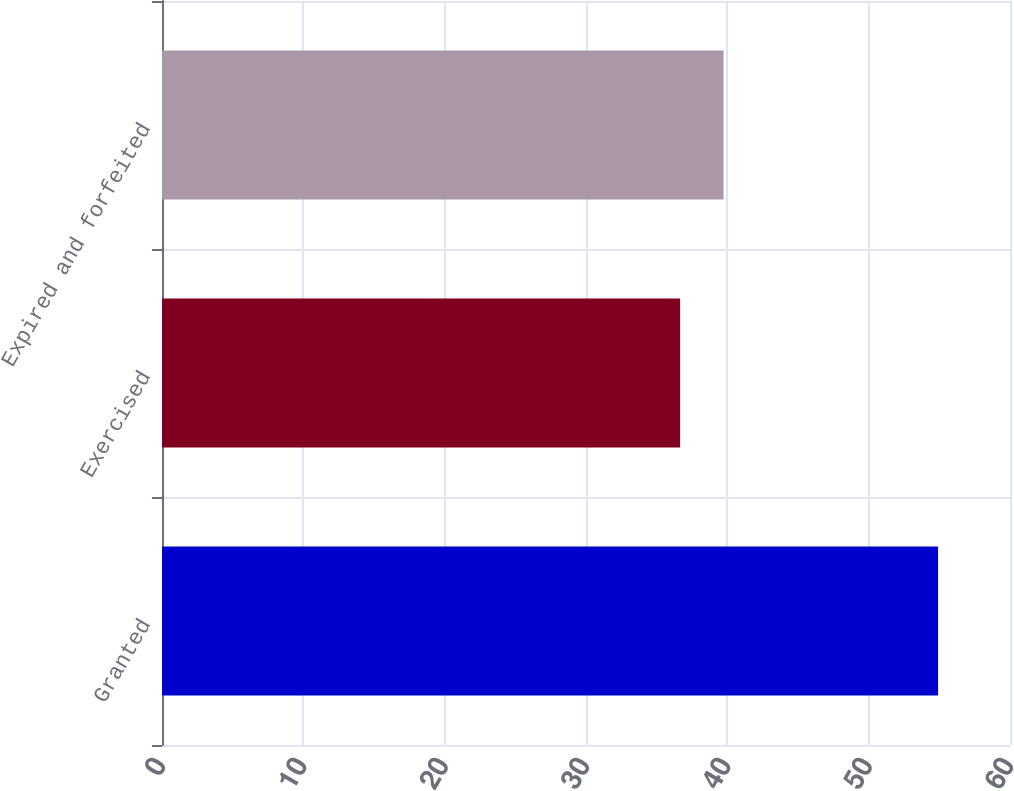Convert chart to OTSL. <chart><loc_0><loc_0><loc_500><loc_500><bar_chart><fcel>Granted<fcel>Exercised<fcel>Expired and forfeited<nl><fcel>54.91<fcel>36.66<fcel>39.73<nl></chart> 